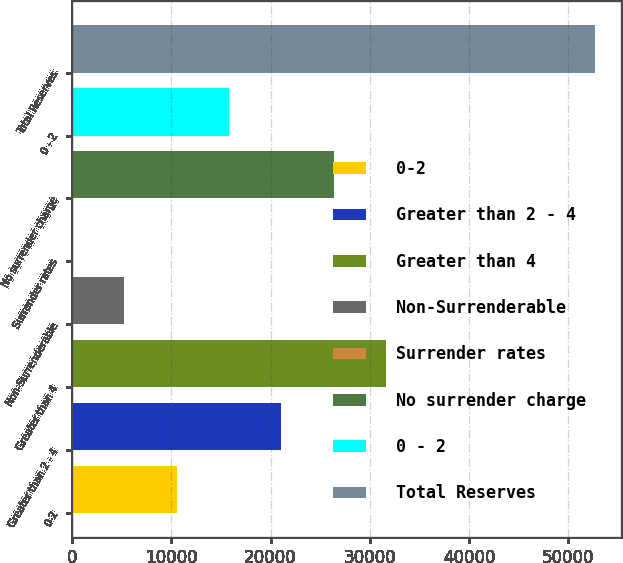Convert chart. <chart><loc_0><loc_0><loc_500><loc_500><bar_chart><fcel>0-2<fcel>Greater than 2 - 4<fcel>Greater than 4<fcel>Non-Surrenderable<fcel>Surrender rates<fcel>No surrender charge<fcel>0 - 2<fcel>Total Reserves<nl><fcel>10548.7<fcel>21082.8<fcel>31616.8<fcel>5281.64<fcel>14.6<fcel>26349.8<fcel>15815.7<fcel>52685<nl></chart> 